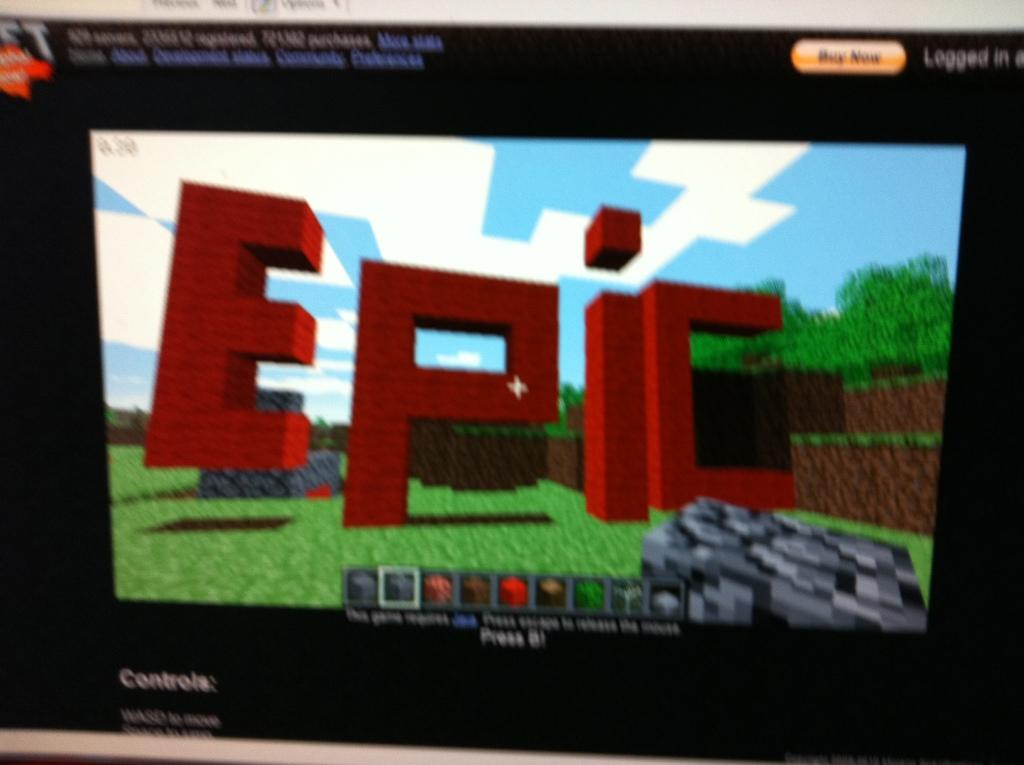<image>
Provide a brief description of the given image. The word Epic is written on this computer screen. 